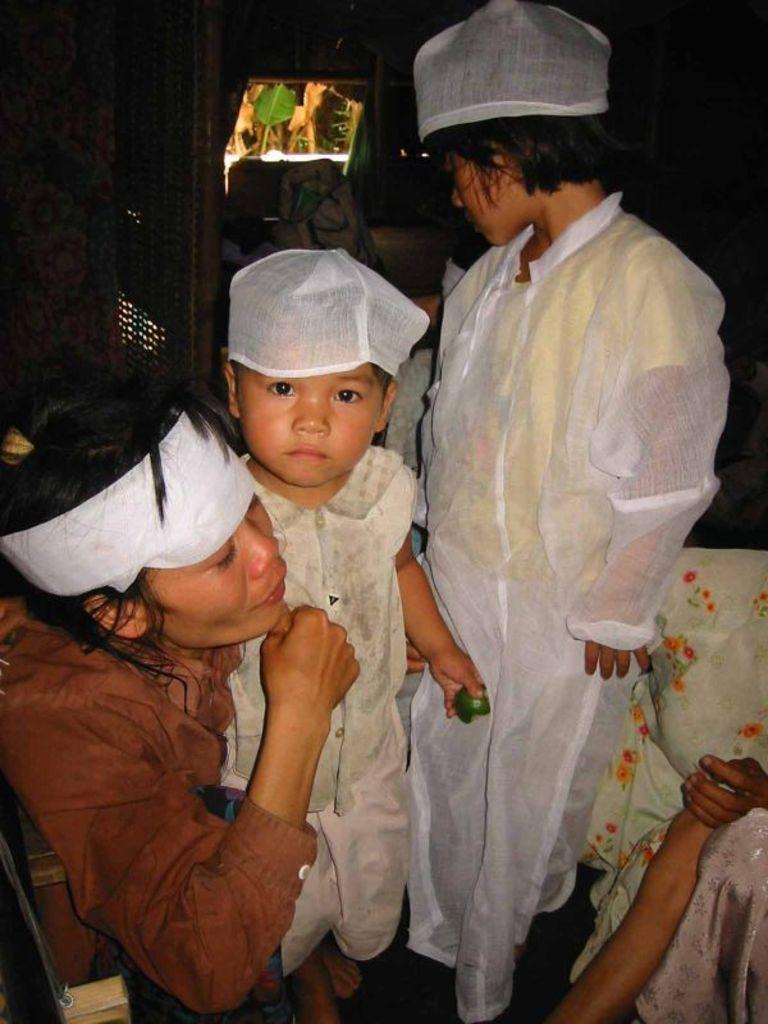In one or two sentences, can you explain what this image depicts? In this image we can see a few people, among them, some people are sitting and some people are standing, in the background we can see some objects. 